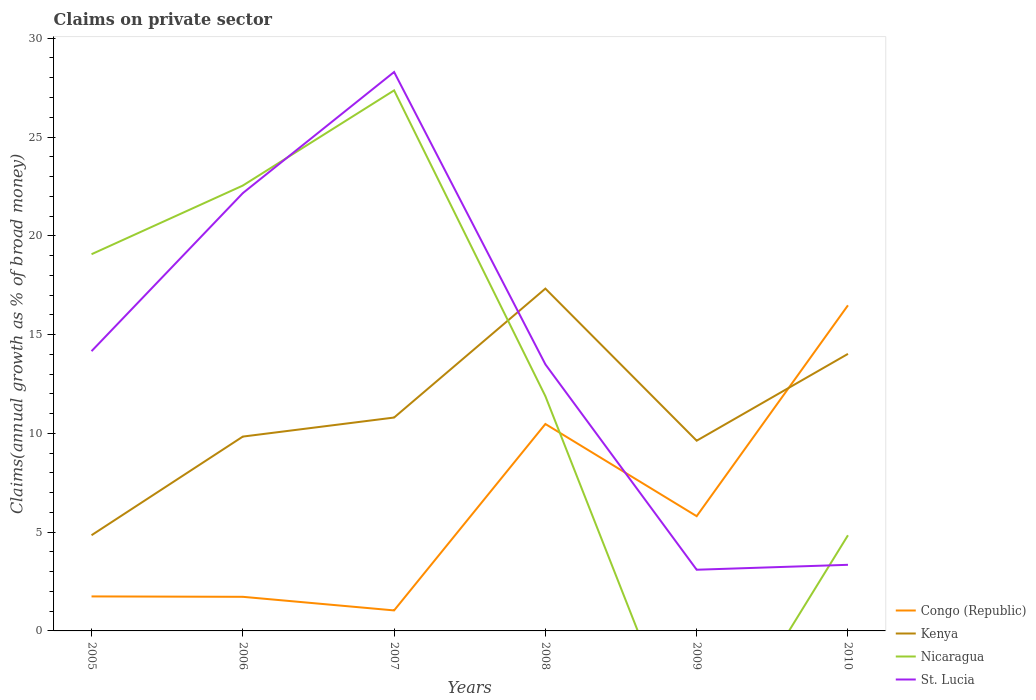Across all years, what is the maximum percentage of broad money claimed on private sector in St. Lucia?
Offer a very short reply. 3.1. What is the total percentage of broad money claimed on private sector in Kenya in the graph?
Your answer should be compact. -12.48. What is the difference between the highest and the second highest percentage of broad money claimed on private sector in Congo (Republic)?
Offer a terse response. 15.44. What is the difference between the highest and the lowest percentage of broad money claimed on private sector in St. Lucia?
Offer a terse response. 3. Is the percentage of broad money claimed on private sector in Kenya strictly greater than the percentage of broad money claimed on private sector in Congo (Republic) over the years?
Give a very brief answer. No. How many years are there in the graph?
Your response must be concise. 6. What is the difference between two consecutive major ticks on the Y-axis?
Offer a terse response. 5. Are the values on the major ticks of Y-axis written in scientific E-notation?
Give a very brief answer. No. Does the graph contain any zero values?
Keep it short and to the point. Yes. Does the graph contain grids?
Make the answer very short. No. How many legend labels are there?
Keep it short and to the point. 4. How are the legend labels stacked?
Make the answer very short. Vertical. What is the title of the graph?
Provide a short and direct response. Claims on private sector. Does "China" appear as one of the legend labels in the graph?
Provide a succinct answer. No. What is the label or title of the X-axis?
Provide a succinct answer. Years. What is the label or title of the Y-axis?
Provide a succinct answer. Claims(annual growth as % of broad money). What is the Claims(annual growth as % of broad money) in Congo (Republic) in 2005?
Ensure brevity in your answer.  1.75. What is the Claims(annual growth as % of broad money) in Kenya in 2005?
Offer a terse response. 4.84. What is the Claims(annual growth as % of broad money) in Nicaragua in 2005?
Your answer should be very brief. 19.07. What is the Claims(annual growth as % of broad money) of St. Lucia in 2005?
Make the answer very short. 14.16. What is the Claims(annual growth as % of broad money) of Congo (Republic) in 2006?
Offer a very short reply. 1.73. What is the Claims(annual growth as % of broad money) of Kenya in 2006?
Offer a terse response. 9.84. What is the Claims(annual growth as % of broad money) of Nicaragua in 2006?
Give a very brief answer. 22.54. What is the Claims(annual growth as % of broad money) of St. Lucia in 2006?
Keep it short and to the point. 22.16. What is the Claims(annual growth as % of broad money) in Congo (Republic) in 2007?
Give a very brief answer. 1.04. What is the Claims(annual growth as % of broad money) of Kenya in 2007?
Provide a short and direct response. 10.8. What is the Claims(annual growth as % of broad money) of Nicaragua in 2007?
Offer a terse response. 27.36. What is the Claims(annual growth as % of broad money) of St. Lucia in 2007?
Make the answer very short. 28.29. What is the Claims(annual growth as % of broad money) in Congo (Republic) in 2008?
Ensure brevity in your answer.  10.47. What is the Claims(annual growth as % of broad money) in Kenya in 2008?
Your answer should be very brief. 17.33. What is the Claims(annual growth as % of broad money) in Nicaragua in 2008?
Your answer should be very brief. 11.88. What is the Claims(annual growth as % of broad money) of St. Lucia in 2008?
Your answer should be very brief. 13.49. What is the Claims(annual growth as % of broad money) of Congo (Republic) in 2009?
Your answer should be very brief. 5.81. What is the Claims(annual growth as % of broad money) of Kenya in 2009?
Keep it short and to the point. 9.63. What is the Claims(annual growth as % of broad money) of St. Lucia in 2009?
Make the answer very short. 3.1. What is the Claims(annual growth as % of broad money) of Congo (Republic) in 2010?
Offer a very short reply. 16.48. What is the Claims(annual growth as % of broad money) of Kenya in 2010?
Provide a short and direct response. 14.02. What is the Claims(annual growth as % of broad money) of Nicaragua in 2010?
Give a very brief answer. 4.84. What is the Claims(annual growth as % of broad money) in St. Lucia in 2010?
Offer a very short reply. 3.35. Across all years, what is the maximum Claims(annual growth as % of broad money) in Congo (Republic)?
Offer a terse response. 16.48. Across all years, what is the maximum Claims(annual growth as % of broad money) of Kenya?
Your answer should be very brief. 17.33. Across all years, what is the maximum Claims(annual growth as % of broad money) of Nicaragua?
Your response must be concise. 27.36. Across all years, what is the maximum Claims(annual growth as % of broad money) of St. Lucia?
Your response must be concise. 28.29. Across all years, what is the minimum Claims(annual growth as % of broad money) of Congo (Republic)?
Give a very brief answer. 1.04. Across all years, what is the minimum Claims(annual growth as % of broad money) in Kenya?
Offer a very short reply. 4.84. Across all years, what is the minimum Claims(annual growth as % of broad money) of St. Lucia?
Your answer should be very brief. 3.1. What is the total Claims(annual growth as % of broad money) of Congo (Republic) in the graph?
Keep it short and to the point. 37.27. What is the total Claims(annual growth as % of broad money) of Kenya in the graph?
Offer a very short reply. 66.46. What is the total Claims(annual growth as % of broad money) in Nicaragua in the graph?
Your answer should be very brief. 85.69. What is the total Claims(annual growth as % of broad money) of St. Lucia in the graph?
Provide a short and direct response. 84.55. What is the difference between the Claims(annual growth as % of broad money) in Congo (Republic) in 2005 and that in 2006?
Ensure brevity in your answer.  0.02. What is the difference between the Claims(annual growth as % of broad money) in Kenya in 2005 and that in 2006?
Keep it short and to the point. -4.99. What is the difference between the Claims(annual growth as % of broad money) in Nicaragua in 2005 and that in 2006?
Give a very brief answer. -3.47. What is the difference between the Claims(annual growth as % of broad money) in St. Lucia in 2005 and that in 2006?
Your answer should be very brief. -8. What is the difference between the Claims(annual growth as % of broad money) in Congo (Republic) in 2005 and that in 2007?
Your answer should be compact. 0.71. What is the difference between the Claims(annual growth as % of broad money) in Kenya in 2005 and that in 2007?
Make the answer very short. -5.96. What is the difference between the Claims(annual growth as % of broad money) of Nicaragua in 2005 and that in 2007?
Provide a short and direct response. -8.29. What is the difference between the Claims(annual growth as % of broad money) of St. Lucia in 2005 and that in 2007?
Provide a short and direct response. -14.13. What is the difference between the Claims(annual growth as % of broad money) in Congo (Republic) in 2005 and that in 2008?
Give a very brief answer. -8.73. What is the difference between the Claims(annual growth as % of broad money) in Kenya in 2005 and that in 2008?
Your answer should be very brief. -12.48. What is the difference between the Claims(annual growth as % of broad money) of Nicaragua in 2005 and that in 2008?
Offer a very short reply. 7.19. What is the difference between the Claims(annual growth as % of broad money) of St. Lucia in 2005 and that in 2008?
Keep it short and to the point. 0.67. What is the difference between the Claims(annual growth as % of broad money) of Congo (Republic) in 2005 and that in 2009?
Ensure brevity in your answer.  -4.06. What is the difference between the Claims(annual growth as % of broad money) of Kenya in 2005 and that in 2009?
Ensure brevity in your answer.  -4.79. What is the difference between the Claims(annual growth as % of broad money) in St. Lucia in 2005 and that in 2009?
Offer a terse response. 11.06. What is the difference between the Claims(annual growth as % of broad money) in Congo (Republic) in 2005 and that in 2010?
Provide a short and direct response. -14.73. What is the difference between the Claims(annual growth as % of broad money) in Kenya in 2005 and that in 2010?
Provide a short and direct response. -9.18. What is the difference between the Claims(annual growth as % of broad money) of Nicaragua in 2005 and that in 2010?
Your answer should be compact. 14.23. What is the difference between the Claims(annual growth as % of broad money) of St. Lucia in 2005 and that in 2010?
Your response must be concise. 10.81. What is the difference between the Claims(annual growth as % of broad money) of Congo (Republic) in 2006 and that in 2007?
Keep it short and to the point. 0.69. What is the difference between the Claims(annual growth as % of broad money) in Kenya in 2006 and that in 2007?
Offer a very short reply. -0.96. What is the difference between the Claims(annual growth as % of broad money) in Nicaragua in 2006 and that in 2007?
Give a very brief answer. -4.82. What is the difference between the Claims(annual growth as % of broad money) of St. Lucia in 2006 and that in 2007?
Give a very brief answer. -6.13. What is the difference between the Claims(annual growth as % of broad money) in Congo (Republic) in 2006 and that in 2008?
Provide a short and direct response. -8.75. What is the difference between the Claims(annual growth as % of broad money) in Kenya in 2006 and that in 2008?
Offer a very short reply. -7.49. What is the difference between the Claims(annual growth as % of broad money) of Nicaragua in 2006 and that in 2008?
Ensure brevity in your answer.  10.66. What is the difference between the Claims(annual growth as % of broad money) in St. Lucia in 2006 and that in 2008?
Provide a short and direct response. 8.67. What is the difference between the Claims(annual growth as % of broad money) in Congo (Republic) in 2006 and that in 2009?
Make the answer very short. -4.08. What is the difference between the Claims(annual growth as % of broad money) of Kenya in 2006 and that in 2009?
Offer a very short reply. 0.21. What is the difference between the Claims(annual growth as % of broad money) in St. Lucia in 2006 and that in 2009?
Make the answer very short. 19.06. What is the difference between the Claims(annual growth as % of broad money) in Congo (Republic) in 2006 and that in 2010?
Provide a succinct answer. -14.75. What is the difference between the Claims(annual growth as % of broad money) in Kenya in 2006 and that in 2010?
Your response must be concise. -4.19. What is the difference between the Claims(annual growth as % of broad money) of Nicaragua in 2006 and that in 2010?
Ensure brevity in your answer.  17.7. What is the difference between the Claims(annual growth as % of broad money) in St. Lucia in 2006 and that in 2010?
Your answer should be compact. 18.81. What is the difference between the Claims(annual growth as % of broad money) in Congo (Republic) in 2007 and that in 2008?
Your answer should be very brief. -9.44. What is the difference between the Claims(annual growth as % of broad money) of Kenya in 2007 and that in 2008?
Make the answer very short. -6.53. What is the difference between the Claims(annual growth as % of broad money) of Nicaragua in 2007 and that in 2008?
Offer a terse response. 15.48. What is the difference between the Claims(annual growth as % of broad money) of St. Lucia in 2007 and that in 2008?
Your answer should be compact. 14.8. What is the difference between the Claims(annual growth as % of broad money) in Congo (Republic) in 2007 and that in 2009?
Make the answer very short. -4.77. What is the difference between the Claims(annual growth as % of broad money) of Kenya in 2007 and that in 2009?
Provide a succinct answer. 1.17. What is the difference between the Claims(annual growth as % of broad money) of St. Lucia in 2007 and that in 2009?
Provide a succinct answer. 25.19. What is the difference between the Claims(annual growth as % of broad money) in Congo (Republic) in 2007 and that in 2010?
Make the answer very short. -15.44. What is the difference between the Claims(annual growth as % of broad money) of Kenya in 2007 and that in 2010?
Your answer should be very brief. -3.22. What is the difference between the Claims(annual growth as % of broad money) in Nicaragua in 2007 and that in 2010?
Your answer should be compact. 22.52. What is the difference between the Claims(annual growth as % of broad money) in St. Lucia in 2007 and that in 2010?
Your answer should be very brief. 24.94. What is the difference between the Claims(annual growth as % of broad money) of Congo (Republic) in 2008 and that in 2009?
Provide a succinct answer. 4.67. What is the difference between the Claims(annual growth as % of broad money) in Kenya in 2008 and that in 2009?
Your response must be concise. 7.7. What is the difference between the Claims(annual growth as % of broad money) of St. Lucia in 2008 and that in 2009?
Provide a succinct answer. 10.4. What is the difference between the Claims(annual growth as % of broad money) of Congo (Republic) in 2008 and that in 2010?
Keep it short and to the point. -6.01. What is the difference between the Claims(annual growth as % of broad money) of Kenya in 2008 and that in 2010?
Your answer should be very brief. 3.3. What is the difference between the Claims(annual growth as % of broad money) of Nicaragua in 2008 and that in 2010?
Offer a very short reply. 7.04. What is the difference between the Claims(annual growth as % of broad money) of St. Lucia in 2008 and that in 2010?
Provide a succinct answer. 10.15. What is the difference between the Claims(annual growth as % of broad money) of Congo (Republic) in 2009 and that in 2010?
Provide a succinct answer. -10.67. What is the difference between the Claims(annual growth as % of broad money) of Kenya in 2009 and that in 2010?
Offer a very short reply. -4.39. What is the difference between the Claims(annual growth as % of broad money) of St. Lucia in 2009 and that in 2010?
Your response must be concise. -0.25. What is the difference between the Claims(annual growth as % of broad money) in Congo (Republic) in 2005 and the Claims(annual growth as % of broad money) in Kenya in 2006?
Keep it short and to the point. -8.09. What is the difference between the Claims(annual growth as % of broad money) in Congo (Republic) in 2005 and the Claims(annual growth as % of broad money) in Nicaragua in 2006?
Provide a succinct answer. -20.8. What is the difference between the Claims(annual growth as % of broad money) of Congo (Republic) in 2005 and the Claims(annual growth as % of broad money) of St. Lucia in 2006?
Offer a very short reply. -20.41. What is the difference between the Claims(annual growth as % of broad money) in Kenya in 2005 and the Claims(annual growth as % of broad money) in Nicaragua in 2006?
Make the answer very short. -17.7. What is the difference between the Claims(annual growth as % of broad money) in Kenya in 2005 and the Claims(annual growth as % of broad money) in St. Lucia in 2006?
Your answer should be compact. -17.32. What is the difference between the Claims(annual growth as % of broad money) in Nicaragua in 2005 and the Claims(annual growth as % of broad money) in St. Lucia in 2006?
Provide a short and direct response. -3.09. What is the difference between the Claims(annual growth as % of broad money) in Congo (Republic) in 2005 and the Claims(annual growth as % of broad money) in Kenya in 2007?
Your answer should be compact. -9.05. What is the difference between the Claims(annual growth as % of broad money) in Congo (Republic) in 2005 and the Claims(annual growth as % of broad money) in Nicaragua in 2007?
Ensure brevity in your answer.  -25.61. What is the difference between the Claims(annual growth as % of broad money) in Congo (Republic) in 2005 and the Claims(annual growth as % of broad money) in St. Lucia in 2007?
Your answer should be compact. -26.54. What is the difference between the Claims(annual growth as % of broad money) of Kenya in 2005 and the Claims(annual growth as % of broad money) of Nicaragua in 2007?
Offer a terse response. -22.52. What is the difference between the Claims(annual growth as % of broad money) in Kenya in 2005 and the Claims(annual growth as % of broad money) in St. Lucia in 2007?
Give a very brief answer. -23.45. What is the difference between the Claims(annual growth as % of broad money) in Nicaragua in 2005 and the Claims(annual growth as % of broad money) in St. Lucia in 2007?
Your answer should be very brief. -9.22. What is the difference between the Claims(annual growth as % of broad money) of Congo (Republic) in 2005 and the Claims(annual growth as % of broad money) of Kenya in 2008?
Make the answer very short. -15.58. What is the difference between the Claims(annual growth as % of broad money) in Congo (Republic) in 2005 and the Claims(annual growth as % of broad money) in Nicaragua in 2008?
Make the answer very short. -10.13. What is the difference between the Claims(annual growth as % of broad money) of Congo (Republic) in 2005 and the Claims(annual growth as % of broad money) of St. Lucia in 2008?
Your response must be concise. -11.75. What is the difference between the Claims(annual growth as % of broad money) in Kenya in 2005 and the Claims(annual growth as % of broad money) in Nicaragua in 2008?
Give a very brief answer. -7.04. What is the difference between the Claims(annual growth as % of broad money) in Kenya in 2005 and the Claims(annual growth as % of broad money) in St. Lucia in 2008?
Give a very brief answer. -8.65. What is the difference between the Claims(annual growth as % of broad money) of Nicaragua in 2005 and the Claims(annual growth as % of broad money) of St. Lucia in 2008?
Give a very brief answer. 5.58. What is the difference between the Claims(annual growth as % of broad money) of Congo (Republic) in 2005 and the Claims(annual growth as % of broad money) of Kenya in 2009?
Offer a very short reply. -7.88. What is the difference between the Claims(annual growth as % of broad money) of Congo (Republic) in 2005 and the Claims(annual growth as % of broad money) of St. Lucia in 2009?
Your response must be concise. -1.35. What is the difference between the Claims(annual growth as % of broad money) in Kenya in 2005 and the Claims(annual growth as % of broad money) in St. Lucia in 2009?
Your answer should be compact. 1.75. What is the difference between the Claims(annual growth as % of broad money) of Nicaragua in 2005 and the Claims(annual growth as % of broad money) of St. Lucia in 2009?
Make the answer very short. 15.97. What is the difference between the Claims(annual growth as % of broad money) in Congo (Republic) in 2005 and the Claims(annual growth as % of broad money) in Kenya in 2010?
Ensure brevity in your answer.  -12.28. What is the difference between the Claims(annual growth as % of broad money) in Congo (Republic) in 2005 and the Claims(annual growth as % of broad money) in Nicaragua in 2010?
Make the answer very short. -3.09. What is the difference between the Claims(annual growth as % of broad money) of Congo (Republic) in 2005 and the Claims(annual growth as % of broad money) of St. Lucia in 2010?
Provide a short and direct response. -1.6. What is the difference between the Claims(annual growth as % of broad money) in Kenya in 2005 and the Claims(annual growth as % of broad money) in Nicaragua in 2010?
Make the answer very short. 0. What is the difference between the Claims(annual growth as % of broad money) in Kenya in 2005 and the Claims(annual growth as % of broad money) in St. Lucia in 2010?
Offer a terse response. 1.5. What is the difference between the Claims(annual growth as % of broad money) of Nicaragua in 2005 and the Claims(annual growth as % of broad money) of St. Lucia in 2010?
Keep it short and to the point. 15.72. What is the difference between the Claims(annual growth as % of broad money) in Congo (Republic) in 2006 and the Claims(annual growth as % of broad money) in Kenya in 2007?
Offer a very short reply. -9.07. What is the difference between the Claims(annual growth as % of broad money) in Congo (Republic) in 2006 and the Claims(annual growth as % of broad money) in Nicaragua in 2007?
Your answer should be compact. -25.63. What is the difference between the Claims(annual growth as % of broad money) in Congo (Republic) in 2006 and the Claims(annual growth as % of broad money) in St. Lucia in 2007?
Provide a succinct answer. -26.56. What is the difference between the Claims(annual growth as % of broad money) of Kenya in 2006 and the Claims(annual growth as % of broad money) of Nicaragua in 2007?
Ensure brevity in your answer.  -17.52. What is the difference between the Claims(annual growth as % of broad money) in Kenya in 2006 and the Claims(annual growth as % of broad money) in St. Lucia in 2007?
Keep it short and to the point. -18.45. What is the difference between the Claims(annual growth as % of broad money) of Nicaragua in 2006 and the Claims(annual growth as % of broad money) of St. Lucia in 2007?
Offer a very short reply. -5.75. What is the difference between the Claims(annual growth as % of broad money) of Congo (Republic) in 2006 and the Claims(annual growth as % of broad money) of Kenya in 2008?
Provide a short and direct response. -15.6. What is the difference between the Claims(annual growth as % of broad money) in Congo (Republic) in 2006 and the Claims(annual growth as % of broad money) in Nicaragua in 2008?
Give a very brief answer. -10.15. What is the difference between the Claims(annual growth as % of broad money) in Congo (Republic) in 2006 and the Claims(annual growth as % of broad money) in St. Lucia in 2008?
Provide a short and direct response. -11.77. What is the difference between the Claims(annual growth as % of broad money) of Kenya in 2006 and the Claims(annual growth as % of broad money) of Nicaragua in 2008?
Your response must be concise. -2.04. What is the difference between the Claims(annual growth as % of broad money) of Kenya in 2006 and the Claims(annual growth as % of broad money) of St. Lucia in 2008?
Your response must be concise. -3.66. What is the difference between the Claims(annual growth as % of broad money) in Nicaragua in 2006 and the Claims(annual growth as % of broad money) in St. Lucia in 2008?
Keep it short and to the point. 9.05. What is the difference between the Claims(annual growth as % of broad money) of Congo (Republic) in 2006 and the Claims(annual growth as % of broad money) of Kenya in 2009?
Provide a succinct answer. -7.9. What is the difference between the Claims(annual growth as % of broad money) in Congo (Republic) in 2006 and the Claims(annual growth as % of broad money) in St. Lucia in 2009?
Ensure brevity in your answer.  -1.37. What is the difference between the Claims(annual growth as % of broad money) in Kenya in 2006 and the Claims(annual growth as % of broad money) in St. Lucia in 2009?
Provide a succinct answer. 6.74. What is the difference between the Claims(annual growth as % of broad money) of Nicaragua in 2006 and the Claims(annual growth as % of broad money) of St. Lucia in 2009?
Offer a very short reply. 19.45. What is the difference between the Claims(annual growth as % of broad money) in Congo (Republic) in 2006 and the Claims(annual growth as % of broad money) in Kenya in 2010?
Your answer should be very brief. -12.3. What is the difference between the Claims(annual growth as % of broad money) of Congo (Republic) in 2006 and the Claims(annual growth as % of broad money) of Nicaragua in 2010?
Give a very brief answer. -3.11. What is the difference between the Claims(annual growth as % of broad money) in Congo (Republic) in 2006 and the Claims(annual growth as % of broad money) in St. Lucia in 2010?
Offer a terse response. -1.62. What is the difference between the Claims(annual growth as % of broad money) of Kenya in 2006 and the Claims(annual growth as % of broad money) of Nicaragua in 2010?
Offer a very short reply. 5. What is the difference between the Claims(annual growth as % of broad money) of Kenya in 2006 and the Claims(annual growth as % of broad money) of St. Lucia in 2010?
Make the answer very short. 6.49. What is the difference between the Claims(annual growth as % of broad money) of Nicaragua in 2006 and the Claims(annual growth as % of broad money) of St. Lucia in 2010?
Offer a terse response. 19.2. What is the difference between the Claims(annual growth as % of broad money) of Congo (Republic) in 2007 and the Claims(annual growth as % of broad money) of Kenya in 2008?
Give a very brief answer. -16.29. What is the difference between the Claims(annual growth as % of broad money) of Congo (Republic) in 2007 and the Claims(annual growth as % of broad money) of Nicaragua in 2008?
Your answer should be compact. -10.84. What is the difference between the Claims(annual growth as % of broad money) of Congo (Republic) in 2007 and the Claims(annual growth as % of broad money) of St. Lucia in 2008?
Your response must be concise. -12.46. What is the difference between the Claims(annual growth as % of broad money) in Kenya in 2007 and the Claims(annual growth as % of broad money) in Nicaragua in 2008?
Give a very brief answer. -1.08. What is the difference between the Claims(annual growth as % of broad money) in Kenya in 2007 and the Claims(annual growth as % of broad money) in St. Lucia in 2008?
Your answer should be compact. -2.69. What is the difference between the Claims(annual growth as % of broad money) of Nicaragua in 2007 and the Claims(annual growth as % of broad money) of St. Lucia in 2008?
Ensure brevity in your answer.  13.87. What is the difference between the Claims(annual growth as % of broad money) of Congo (Republic) in 2007 and the Claims(annual growth as % of broad money) of Kenya in 2009?
Ensure brevity in your answer.  -8.59. What is the difference between the Claims(annual growth as % of broad money) of Congo (Republic) in 2007 and the Claims(annual growth as % of broad money) of St. Lucia in 2009?
Offer a very short reply. -2.06. What is the difference between the Claims(annual growth as % of broad money) of Kenya in 2007 and the Claims(annual growth as % of broad money) of St. Lucia in 2009?
Provide a succinct answer. 7.7. What is the difference between the Claims(annual growth as % of broad money) in Nicaragua in 2007 and the Claims(annual growth as % of broad money) in St. Lucia in 2009?
Give a very brief answer. 24.26. What is the difference between the Claims(annual growth as % of broad money) in Congo (Republic) in 2007 and the Claims(annual growth as % of broad money) in Kenya in 2010?
Offer a terse response. -12.99. What is the difference between the Claims(annual growth as % of broad money) of Congo (Republic) in 2007 and the Claims(annual growth as % of broad money) of Nicaragua in 2010?
Keep it short and to the point. -3.8. What is the difference between the Claims(annual growth as % of broad money) in Congo (Republic) in 2007 and the Claims(annual growth as % of broad money) in St. Lucia in 2010?
Your answer should be very brief. -2.31. What is the difference between the Claims(annual growth as % of broad money) of Kenya in 2007 and the Claims(annual growth as % of broad money) of Nicaragua in 2010?
Provide a succinct answer. 5.96. What is the difference between the Claims(annual growth as % of broad money) in Kenya in 2007 and the Claims(annual growth as % of broad money) in St. Lucia in 2010?
Your answer should be very brief. 7.45. What is the difference between the Claims(annual growth as % of broad money) in Nicaragua in 2007 and the Claims(annual growth as % of broad money) in St. Lucia in 2010?
Keep it short and to the point. 24.01. What is the difference between the Claims(annual growth as % of broad money) of Congo (Republic) in 2008 and the Claims(annual growth as % of broad money) of Kenya in 2009?
Your response must be concise. 0.85. What is the difference between the Claims(annual growth as % of broad money) in Congo (Republic) in 2008 and the Claims(annual growth as % of broad money) in St. Lucia in 2009?
Ensure brevity in your answer.  7.38. What is the difference between the Claims(annual growth as % of broad money) in Kenya in 2008 and the Claims(annual growth as % of broad money) in St. Lucia in 2009?
Provide a succinct answer. 14.23. What is the difference between the Claims(annual growth as % of broad money) in Nicaragua in 2008 and the Claims(annual growth as % of broad money) in St. Lucia in 2009?
Make the answer very short. 8.78. What is the difference between the Claims(annual growth as % of broad money) in Congo (Republic) in 2008 and the Claims(annual growth as % of broad money) in Kenya in 2010?
Make the answer very short. -3.55. What is the difference between the Claims(annual growth as % of broad money) in Congo (Republic) in 2008 and the Claims(annual growth as % of broad money) in Nicaragua in 2010?
Offer a terse response. 5.63. What is the difference between the Claims(annual growth as % of broad money) of Congo (Republic) in 2008 and the Claims(annual growth as % of broad money) of St. Lucia in 2010?
Keep it short and to the point. 7.13. What is the difference between the Claims(annual growth as % of broad money) in Kenya in 2008 and the Claims(annual growth as % of broad money) in Nicaragua in 2010?
Give a very brief answer. 12.49. What is the difference between the Claims(annual growth as % of broad money) of Kenya in 2008 and the Claims(annual growth as % of broad money) of St. Lucia in 2010?
Your response must be concise. 13.98. What is the difference between the Claims(annual growth as % of broad money) in Nicaragua in 2008 and the Claims(annual growth as % of broad money) in St. Lucia in 2010?
Make the answer very short. 8.53. What is the difference between the Claims(annual growth as % of broad money) in Congo (Republic) in 2009 and the Claims(annual growth as % of broad money) in Kenya in 2010?
Offer a very short reply. -8.22. What is the difference between the Claims(annual growth as % of broad money) of Congo (Republic) in 2009 and the Claims(annual growth as % of broad money) of Nicaragua in 2010?
Offer a terse response. 0.97. What is the difference between the Claims(annual growth as % of broad money) in Congo (Republic) in 2009 and the Claims(annual growth as % of broad money) in St. Lucia in 2010?
Your response must be concise. 2.46. What is the difference between the Claims(annual growth as % of broad money) in Kenya in 2009 and the Claims(annual growth as % of broad money) in Nicaragua in 2010?
Your response must be concise. 4.79. What is the difference between the Claims(annual growth as % of broad money) of Kenya in 2009 and the Claims(annual growth as % of broad money) of St. Lucia in 2010?
Keep it short and to the point. 6.28. What is the average Claims(annual growth as % of broad money) of Congo (Republic) per year?
Keep it short and to the point. 6.21. What is the average Claims(annual growth as % of broad money) in Kenya per year?
Give a very brief answer. 11.08. What is the average Claims(annual growth as % of broad money) in Nicaragua per year?
Provide a short and direct response. 14.28. What is the average Claims(annual growth as % of broad money) in St. Lucia per year?
Provide a succinct answer. 14.09. In the year 2005, what is the difference between the Claims(annual growth as % of broad money) in Congo (Republic) and Claims(annual growth as % of broad money) in Kenya?
Give a very brief answer. -3.1. In the year 2005, what is the difference between the Claims(annual growth as % of broad money) of Congo (Republic) and Claims(annual growth as % of broad money) of Nicaragua?
Your answer should be compact. -17.32. In the year 2005, what is the difference between the Claims(annual growth as % of broad money) of Congo (Republic) and Claims(annual growth as % of broad money) of St. Lucia?
Provide a short and direct response. -12.41. In the year 2005, what is the difference between the Claims(annual growth as % of broad money) of Kenya and Claims(annual growth as % of broad money) of Nicaragua?
Provide a succinct answer. -14.22. In the year 2005, what is the difference between the Claims(annual growth as % of broad money) of Kenya and Claims(annual growth as % of broad money) of St. Lucia?
Offer a very short reply. -9.32. In the year 2005, what is the difference between the Claims(annual growth as % of broad money) of Nicaragua and Claims(annual growth as % of broad money) of St. Lucia?
Your answer should be very brief. 4.91. In the year 2006, what is the difference between the Claims(annual growth as % of broad money) of Congo (Republic) and Claims(annual growth as % of broad money) of Kenya?
Make the answer very short. -8.11. In the year 2006, what is the difference between the Claims(annual growth as % of broad money) in Congo (Republic) and Claims(annual growth as % of broad money) in Nicaragua?
Your answer should be compact. -20.82. In the year 2006, what is the difference between the Claims(annual growth as % of broad money) of Congo (Republic) and Claims(annual growth as % of broad money) of St. Lucia?
Ensure brevity in your answer.  -20.43. In the year 2006, what is the difference between the Claims(annual growth as % of broad money) in Kenya and Claims(annual growth as % of broad money) in Nicaragua?
Provide a short and direct response. -12.71. In the year 2006, what is the difference between the Claims(annual growth as % of broad money) in Kenya and Claims(annual growth as % of broad money) in St. Lucia?
Your answer should be compact. -12.32. In the year 2006, what is the difference between the Claims(annual growth as % of broad money) in Nicaragua and Claims(annual growth as % of broad money) in St. Lucia?
Offer a very short reply. 0.38. In the year 2007, what is the difference between the Claims(annual growth as % of broad money) of Congo (Republic) and Claims(annual growth as % of broad money) of Kenya?
Provide a short and direct response. -9.76. In the year 2007, what is the difference between the Claims(annual growth as % of broad money) in Congo (Republic) and Claims(annual growth as % of broad money) in Nicaragua?
Make the answer very short. -26.32. In the year 2007, what is the difference between the Claims(annual growth as % of broad money) in Congo (Republic) and Claims(annual growth as % of broad money) in St. Lucia?
Your answer should be very brief. -27.25. In the year 2007, what is the difference between the Claims(annual growth as % of broad money) in Kenya and Claims(annual growth as % of broad money) in Nicaragua?
Your answer should be compact. -16.56. In the year 2007, what is the difference between the Claims(annual growth as % of broad money) in Kenya and Claims(annual growth as % of broad money) in St. Lucia?
Offer a very short reply. -17.49. In the year 2007, what is the difference between the Claims(annual growth as % of broad money) in Nicaragua and Claims(annual growth as % of broad money) in St. Lucia?
Offer a terse response. -0.93. In the year 2008, what is the difference between the Claims(annual growth as % of broad money) of Congo (Republic) and Claims(annual growth as % of broad money) of Kenya?
Make the answer very short. -6.85. In the year 2008, what is the difference between the Claims(annual growth as % of broad money) of Congo (Republic) and Claims(annual growth as % of broad money) of Nicaragua?
Give a very brief answer. -1.41. In the year 2008, what is the difference between the Claims(annual growth as % of broad money) of Congo (Republic) and Claims(annual growth as % of broad money) of St. Lucia?
Your answer should be very brief. -3.02. In the year 2008, what is the difference between the Claims(annual growth as % of broad money) in Kenya and Claims(annual growth as % of broad money) in Nicaragua?
Keep it short and to the point. 5.45. In the year 2008, what is the difference between the Claims(annual growth as % of broad money) in Kenya and Claims(annual growth as % of broad money) in St. Lucia?
Provide a short and direct response. 3.83. In the year 2008, what is the difference between the Claims(annual growth as % of broad money) in Nicaragua and Claims(annual growth as % of broad money) in St. Lucia?
Offer a very short reply. -1.61. In the year 2009, what is the difference between the Claims(annual growth as % of broad money) in Congo (Republic) and Claims(annual growth as % of broad money) in Kenya?
Your response must be concise. -3.82. In the year 2009, what is the difference between the Claims(annual growth as % of broad money) in Congo (Republic) and Claims(annual growth as % of broad money) in St. Lucia?
Make the answer very short. 2.71. In the year 2009, what is the difference between the Claims(annual growth as % of broad money) in Kenya and Claims(annual growth as % of broad money) in St. Lucia?
Your response must be concise. 6.53. In the year 2010, what is the difference between the Claims(annual growth as % of broad money) of Congo (Republic) and Claims(annual growth as % of broad money) of Kenya?
Provide a succinct answer. 2.46. In the year 2010, what is the difference between the Claims(annual growth as % of broad money) of Congo (Republic) and Claims(annual growth as % of broad money) of Nicaragua?
Keep it short and to the point. 11.64. In the year 2010, what is the difference between the Claims(annual growth as % of broad money) of Congo (Republic) and Claims(annual growth as % of broad money) of St. Lucia?
Keep it short and to the point. 13.13. In the year 2010, what is the difference between the Claims(annual growth as % of broad money) in Kenya and Claims(annual growth as % of broad money) in Nicaragua?
Your response must be concise. 9.18. In the year 2010, what is the difference between the Claims(annual growth as % of broad money) of Kenya and Claims(annual growth as % of broad money) of St. Lucia?
Provide a short and direct response. 10.68. In the year 2010, what is the difference between the Claims(annual growth as % of broad money) of Nicaragua and Claims(annual growth as % of broad money) of St. Lucia?
Offer a terse response. 1.49. What is the ratio of the Claims(annual growth as % of broad money) in Congo (Republic) in 2005 to that in 2006?
Your answer should be very brief. 1.01. What is the ratio of the Claims(annual growth as % of broad money) of Kenya in 2005 to that in 2006?
Offer a terse response. 0.49. What is the ratio of the Claims(annual growth as % of broad money) in Nicaragua in 2005 to that in 2006?
Your answer should be compact. 0.85. What is the ratio of the Claims(annual growth as % of broad money) of St. Lucia in 2005 to that in 2006?
Offer a very short reply. 0.64. What is the ratio of the Claims(annual growth as % of broad money) of Congo (Republic) in 2005 to that in 2007?
Keep it short and to the point. 1.68. What is the ratio of the Claims(annual growth as % of broad money) of Kenya in 2005 to that in 2007?
Keep it short and to the point. 0.45. What is the ratio of the Claims(annual growth as % of broad money) in Nicaragua in 2005 to that in 2007?
Give a very brief answer. 0.7. What is the ratio of the Claims(annual growth as % of broad money) of St. Lucia in 2005 to that in 2007?
Provide a succinct answer. 0.5. What is the ratio of the Claims(annual growth as % of broad money) of Congo (Republic) in 2005 to that in 2008?
Offer a very short reply. 0.17. What is the ratio of the Claims(annual growth as % of broad money) of Kenya in 2005 to that in 2008?
Provide a succinct answer. 0.28. What is the ratio of the Claims(annual growth as % of broad money) of Nicaragua in 2005 to that in 2008?
Ensure brevity in your answer.  1.6. What is the ratio of the Claims(annual growth as % of broad money) of St. Lucia in 2005 to that in 2008?
Keep it short and to the point. 1.05. What is the ratio of the Claims(annual growth as % of broad money) of Congo (Republic) in 2005 to that in 2009?
Offer a very short reply. 0.3. What is the ratio of the Claims(annual growth as % of broad money) in Kenya in 2005 to that in 2009?
Provide a succinct answer. 0.5. What is the ratio of the Claims(annual growth as % of broad money) of St. Lucia in 2005 to that in 2009?
Offer a terse response. 4.57. What is the ratio of the Claims(annual growth as % of broad money) in Congo (Republic) in 2005 to that in 2010?
Provide a short and direct response. 0.11. What is the ratio of the Claims(annual growth as % of broad money) in Kenya in 2005 to that in 2010?
Give a very brief answer. 0.35. What is the ratio of the Claims(annual growth as % of broad money) of Nicaragua in 2005 to that in 2010?
Make the answer very short. 3.94. What is the ratio of the Claims(annual growth as % of broad money) in St. Lucia in 2005 to that in 2010?
Keep it short and to the point. 4.23. What is the ratio of the Claims(annual growth as % of broad money) in Congo (Republic) in 2006 to that in 2007?
Offer a very short reply. 1.66. What is the ratio of the Claims(annual growth as % of broad money) in Kenya in 2006 to that in 2007?
Make the answer very short. 0.91. What is the ratio of the Claims(annual growth as % of broad money) of Nicaragua in 2006 to that in 2007?
Provide a short and direct response. 0.82. What is the ratio of the Claims(annual growth as % of broad money) in St. Lucia in 2006 to that in 2007?
Your answer should be compact. 0.78. What is the ratio of the Claims(annual growth as % of broad money) in Congo (Republic) in 2006 to that in 2008?
Make the answer very short. 0.16. What is the ratio of the Claims(annual growth as % of broad money) of Kenya in 2006 to that in 2008?
Your answer should be compact. 0.57. What is the ratio of the Claims(annual growth as % of broad money) in Nicaragua in 2006 to that in 2008?
Your answer should be very brief. 1.9. What is the ratio of the Claims(annual growth as % of broad money) of St. Lucia in 2006 to that in 2008?
Provide a short and direct response. 1.64. What is the ratio of the Claims(annual growth as % of broad money) in Congo (Republic) in 2006 to that in 2009?
Offer a very short reply. 0.3. What is the ratio of the Claims(annual growth as % of broad money) of Kenya in 2006 to that in 2009?
Provide a short and direct response. 1.02. What is the ratio of the Claims(annual growth as % of broad money) in St. Lucia in 2006 to that in 2009?
Provide a succinct answer. 7.16. What is the ratio of the Claims(annual growth as % of broad money) in Congo (Republic) in 2006 to that in 2010?
Ensure brevity in your answer.  0.1. What is the ratio of the Claims(annual growth as % of broad money) of Kenya in 2006 to that in 2010?
Your response must be concise. 0.7. What is the ratio of the Claims(annual growth as % of broad money) in Nicaragua in 2006 to that in 2010?
Your response must be concise. 4.66. What is the ratio of the Claims(annual growth as % of broad money) of St. Lucia in 2006 to that in 2010?
Offer a terse response. 6.62. What is the ratio of the Claims(annual growth as % of broad money) of Congo (Republic) in 2007 to that in 2008?
Offer a very short reply. 0.1. What is the ratio of the Claims(annual growth as % of broad money) of Kenya in 2007 to that in 2008?
Ensure brevity in your answer.  0.62. What is the ratio of the Claims(annual growth as % of broad money) of Nicaragua in 2007 to that in 2008?
Give a very brief answer. 2.3. What is the ratio of the Claims(annual growth as % of broad money) of St. Lucia in 2007 to that in 2008?
Your answer should be compact. 2.1. What is the ratio of the Claims(annual growth as % of broad money) in Congo (Republic) in 2007 to that in 2009?
Ensure brevity in your answer.  0.18. What is the ratio of the Claims(annual growth as % of broad money) of Kenya in 2007 to that in 2009?
Ensure brevity in your answer.  1.12. What is the ratio of the Claims(annual growth as % of broad money) of St. Lucia in 2007 to that in 2009?
Ensure brevity in your answer.  9.13. What is the ratio of the Claims(annual growth as % of broad money) in Congo (Republic) in 2007 to that in 2010?
Ensure brevity in your answer.  0.06. What is the ratio of the Claims(annual growth as % of broad money) in Kenya in 2007 to that in 2010?
Your answer should be very brief. 0.77. What is the ratio of the Claims(annual growth as % of broad money) of Nicaragua in 2007 to that in 2010?
Offer a terse response. 5.65. What is the ratio of the Claims(annual growth as % of broad money) in St. Lucia in 2007 to that in 2010?
Ensure brevity in your answer.  8.45. What is the ratio of the Claims(annual growth as % of broad money) in Congo (Republic) in 2008 to that in 2009?
Offer a very short reply. 1.8. What is the ratio of the Claims(annual growth as % of broad money) in Kenya in 2008 to that in 2009?
Provide a succinct answer. 1.8. What is the ratio of the Claims(annual growth as % of broad money) in St. Lucia in 2008 to that in 2009?
Provide a short and direct response. 4.36. What is the ratio of the Claims(annual growth as % of broad money) in Congo (Republic) in 2008 to that in 2010?
Offer a terse response. 0.64. What is the ratio of the Claims(annual growth as % of broad money) of Kenya in 2008 to that in 2010?
Your answer should be compact. 1.24. What is the ratio of the Claims(annual growth as % of broad money) of Nicaragua in 2008 to that in 2010?
Your answer should be very brief. 2.45. What is the ratio of the Claims(annual growth as % of broad money) in St. Lucia in 2008 to that in 2010?
Provide a short and direct response. 4.03. What is the ratio of the Claims(annual growth as % of broad money) in Congo (Republic) in 2009 to that in 2010?
Your answer should be very brief. 0.35. What is the ratio of the Claims(annual growth as % of broad money) in Kenya in 2009 to that in 2010?
Offer a terse response. 0.69. What is the ratio of the Claims(annual growth as % of broad money) of St. Lucia in 2009 to that in 2010?
Provide a short and direct response. 0.93. What is the difference between the highest and the second highest Claims(annual growth as % of broad money) in Congo (Republic)?
Give a very brief answer. 6.01. What is the difference between the highest and the second highest Claims(annual growth as % of broad money) of Kenya?
Provide a short and direct response. 3.3. What is the difference between the highest and the second highest Claims(annual growth as % of broad money) in Nicaragua?
Ensure brevity in your answer.  4.82. What is the difference between the highest and the second highest Claims(annual growth as % of broad money) of St. Lucia?
Your answer should be very brief. 6.13. What is the difference between the highest and the lowest Claims(annual growth as % of broad money) of Congo (Republic)?
Offer a very short reply. 15.44. What is the difference between the highest and the lowest Claims(annual growth as % of broad money) of Kenya?
Ensure brevity in your answer.  12.48. What is the difference between the highest and the lowest Claims(annual growth as % of broad money) of Nicaragua?
Offer a very short reply. 27.36. What is the difference between the highest and the lowest Claims(annual growth as % of broad money) in St. Lucia?
Give a very brief answer. 25.19. 